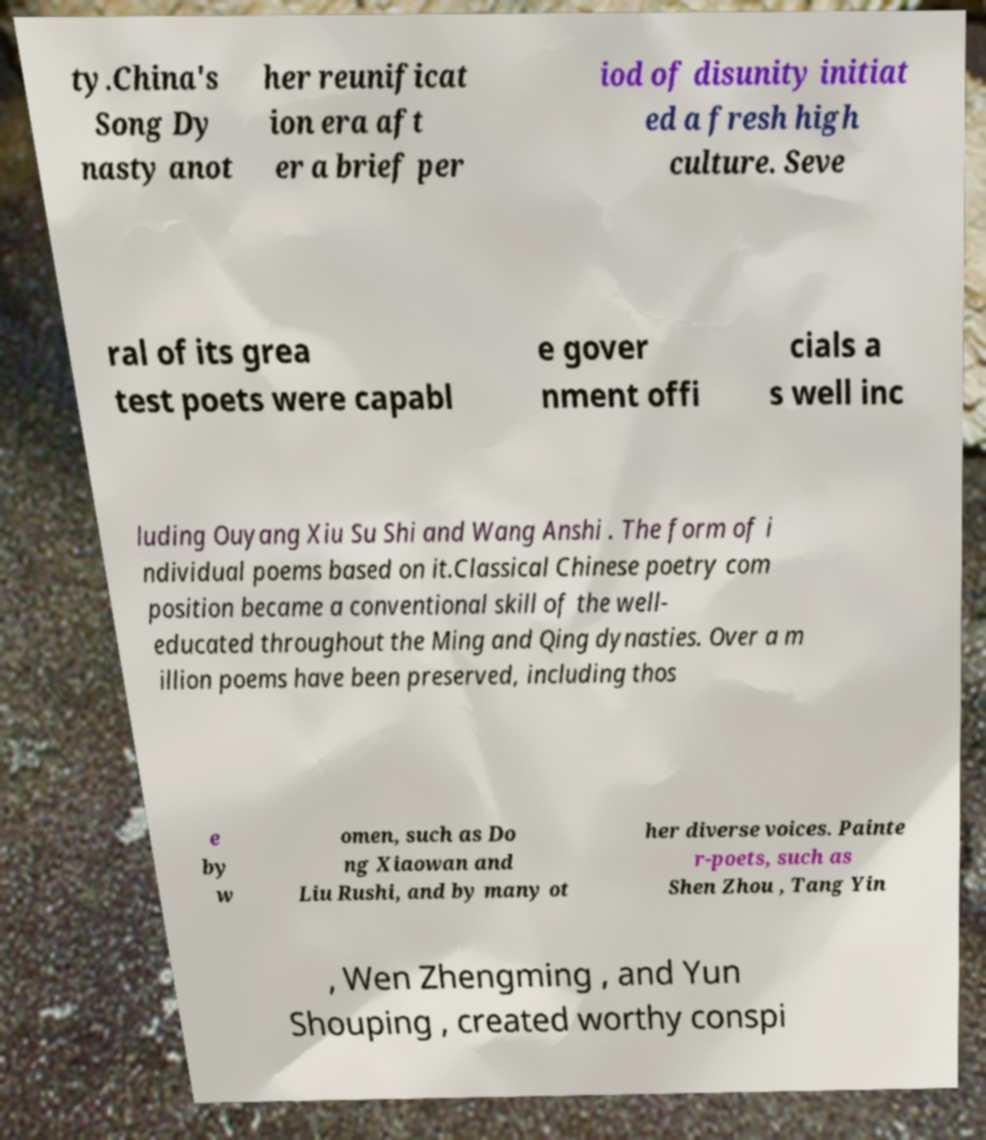Could you assist in decoding the text presented in this image and type it out clearly? ty.China's Song Dy nasty anot her reunificat ion era aft er a brief per iod of disunity initiat ed a fresh high culture. Seve ral of its grea test poets were capabl e gover nment offi cials a s well inc luding Ouyang Xiu Su Shi and Wang Anshi . The form of i ndividual poems based on it.Classical Chinese poetry com position became a conventional skill of the well- educated throughout the Ming and Qing dynasties. Over a m illion poems have been preserved, including thos e by w omen, such as Do ng Xiaowan and Liu Rushi, and by many ot her diverse voices. Painte r-poets, such as Shen Zhou , Tang Yin , Wen Zhengming , and Yun Shouping , created worthy conspi 